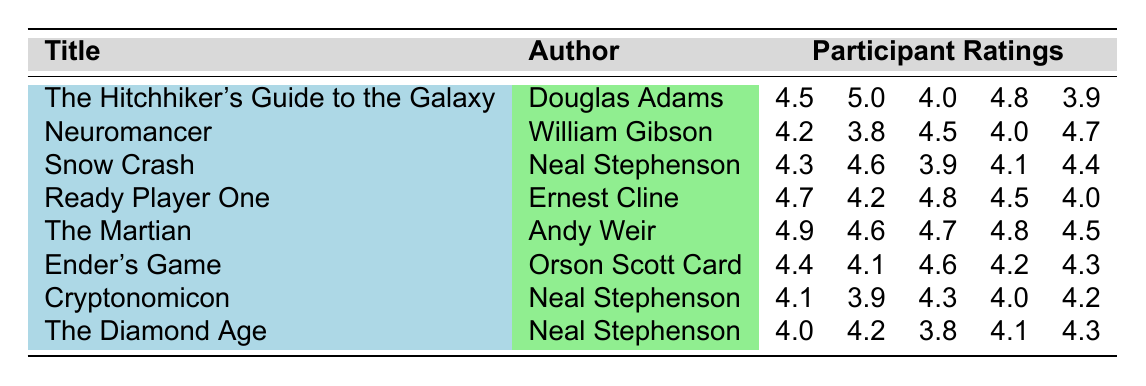What is the highest rating for "The Martian"? Looking at the ratings for "The Martian", which are 4.9, 4.6, 4.7, 4.8, and 4.5, the highest value among these is 4.9.
Answer: 4.9 What is the lowest rating received by "Neuromancer"? The ratings for "Neuromancer" are 4.2, 3.8, 4.5, 4.0, and 4.7. The lowest value in this list is 3.8.
Answer: 3.8 What is the average rating for "Snow Crash"? To find the average rating, sum the ratings: 4.3 + 4.6 + 3.9 + 4.1 + 4.4 = 21.3. There are 5 ratings, so the average is 21.3 / 5 = 4.26.
Answer: 4.26 Did "Ender's Game" receive a rating higher than 4.5 from all participants? The ratings for "Ender's Game" are 4.4, 4.1, 4.6, 4.2, and 4.3. None of these ratings exceed 4.5, as the highest is 4.6, but one rating is 4.1, therefore not all ratings are higher than 4.5.
Answer: No Which book has the highest combined rating total? Calculate the total ratings for each book: "The Hitchhiker's Guide to the Galaxy" = 21.2, "Neuromancer" = 20.2, "Snow Crash" = 21.3, "Ready Player One" = 22.2, "The Martian" = 22.5, "Ender's Game" = 21.6, "Cryptonomicon" = 20.5, "The Diamond Age" = 20.4. The highest total is for "The Martian" with 22.5.
Answer: The Martian What rating did "The Diamond Age" receive for the second participant? The ratings for "The Diamond Age" are 4.0, 4.2, 3.8, 4.1, and 4.3. The second participant's rating is 4.2.
Answer: 4.2 How many books have an average rating of at least 4.5? Calculate the averages: "The Hitchhiker's Guide to the Galaxy" = 4.5, "Neuromancer" = 4.24, "Snow Crash" = 4.34, "Ready Player One" = 4.44, "The Martian" = 4.7, "Ender's Game" = 4.32, "Cryptonomicon" = 4.1, "The Diamond Age" = 4.12. Only "The Martian" and "The Hitchhiker's Guide to the Galaxy" meet this criterion. Thus, there are 2 books.
Answer: 2 Is "Ready Player One" rated higher on average than "Cryptonomicon"? The average rating for "Ready Player One" is (4.7+4.2+4.8+4.5+4.0)/5 = 4.44, and for "Cryptonomicon" it is (4.1+3.9+4.3+4.0+4.2)/5 = 4.1. Since 4.44 > 4.1, "Ready Player One" has a higher average.
Answer: Yes Which author has the most books listed in the table? The author Neal Stephenson appears three times: for "Snow Crash", "Cryptonomicon", and "The Diamond Age". No other author has more than two books.
Answer: Neal Stephenson 